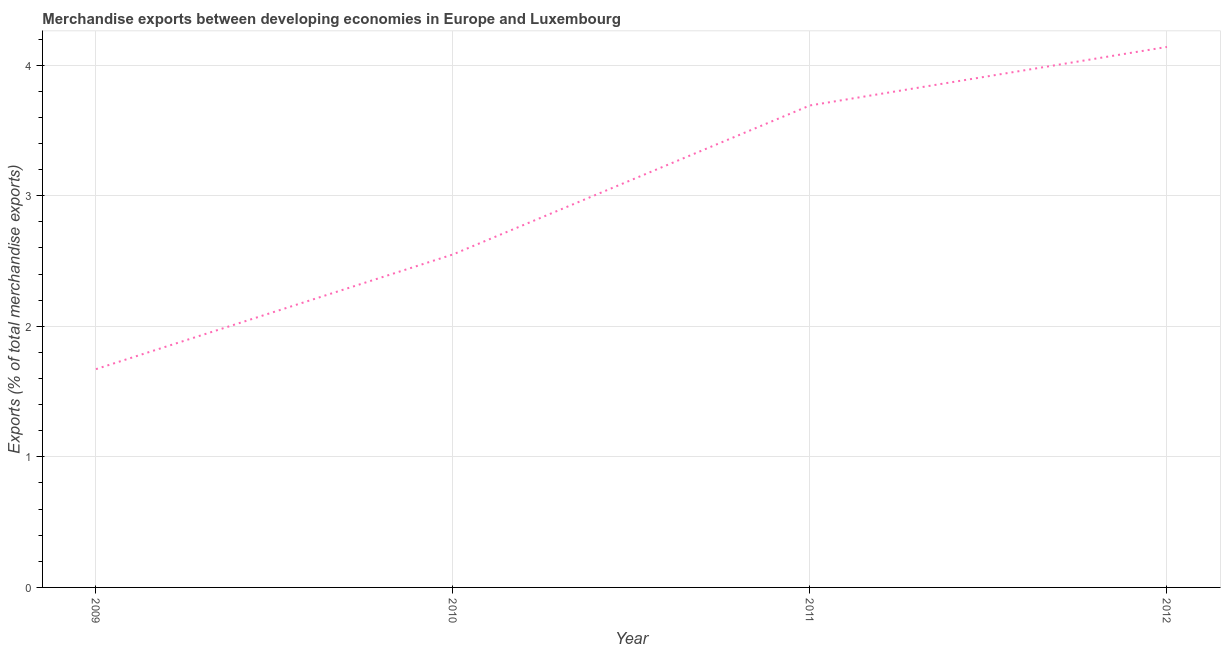What is the merchandise exports in 2010?
Make the answer very short. 2.55. Across all years, what is the maximum merchandise exports?
Offer a very short reply. 4.14. Across all years, what is the minimum merchandise exports?
Provide a short and direct response. 1.67. In which year was the merchandise exports maximum?
Provide a short and direct response. 2012. What is the sum of the merchandise exports?
Offer a very short reply. 12.05. What is the difference between the merchandise exports in 2010 and 2011?
Keep it short and to the point. -1.14. What is the average merchandise exports per year?
Offer a very short reply. 3.01. What is the median merchandise exports?
Offer a terse response. 3.12. Do a majority of the years between 2009 and 2012 (inclusive) have merchandise exports greater than 0.4 %?
Make the answer very short. Yes. What is the ratio of the merchandise exports in 2011 to that in 2012?
Keep it short and to the point. 0.89. Is the merchandise exports in 2009 less than that in 2012?
Give a very brief answer. Yes. Is the difference between the merchandise exports in 2010 and 2011 greater than the difference between any two years?
Provide a short and direct response. No. What is the difference between the highest and the second highest merchandise exports?
Your answer should be compact. 0.45. Is the sum of the merchandise exports in 2010 and 2012 greater than the maximum merchandise exports across all years?
Offer a terse response. Yes. What is the difference between the highest and the lowest merchandise exports?
Your response must be concise. 2.47. How many years are there in the graph?
Ensure brevity in your answer.  4. What is the difference between two consecutive major ticks on the Y-axis?
Ensure brevity in your answer.  1. Are the values on the major ticks of Y-axis written in scientific E-notation?
Make the answer very short. No. Does the graph contain any zero values?
Offer a terse response. No. What is the title of the graph?
Your answer should be compact. Merchandise exports between developing economies in Europe and Luxembourg. What is the label or title of the Y-axis?
Provide a succinct answer. Exports (% of total merchandise exports). What is the Exports (% of total merchandise exports) of 2009?
Make the answer very short. 1.67. What is the Exports (% of total merchandise exports) in 2010?
Keep it short and to the point. 2.55. What is the Exports (% of total merchandise exports) in 2011?
Your answer should be compact. 3.69. What is the Exports (% of total merchandise exports) of 2012?
Offer a very short reply. 4.14. What is the difference between the Exports (% of total merchandise exports) in 2009 and 2010?
Your response must be concise. -0.88. What is the difference between the Exports (% of total merchandise exports) in 2009 and 2011?
Make the answer very short. -2.02. What is the difference between the Exports (% of total merchandise exports) in 2009 and 2012?
Give a very brief answer. -2.47. What is the difference between the Exports (% of total merchandise exports) in 2010 and 2011?
Your answer should be very brief. -1.14. What is the difference between the Exports (% of total merchandise exports) in 2010 and 2012?
Offer a very short reply. -1.59. What is the difference between the Exports (% of total merchandise exports) in 2011 and 2012?
Your answer should be very brief. -0.45. What is the ratio of the Exports (% of total merchandise exports) in 2009 to that in 2010?
Your response must be concise. 0.66. What is the ratio of the Exports (% of total merchandise exports) in 2009 to that in 2011?
Give a very brief answer. 0.45. What is the ratio of the Exports (% of total merchandise exports) in 2009 to that in 2012?
Your answer should be compact. 0.4. What is the ratio of the Exports (% of total merchandise exports) in 2010 to that in 2011?
Provide a short and direct response. 0.69. What is the ratio of the Exports (% of total merchandise exports) in 2010 to that in 2012?
Your answer should be compact. 0.62. What is the ratio of the Exports (% of total merchandise exports) in 2011 to that in 2012?
Offer a terse response. 0.89. 